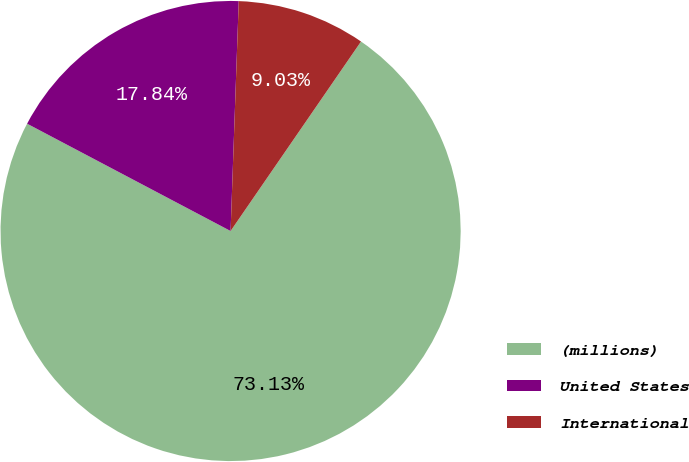<chart> <loc_0><loc_0><loc_500><loc_500><pie_chart><fcel>(millions)<fcel>United States<fcel>International<nl><fcel>73.13%<fcel>17.84%<fcel>9.03%<nl></chart> 